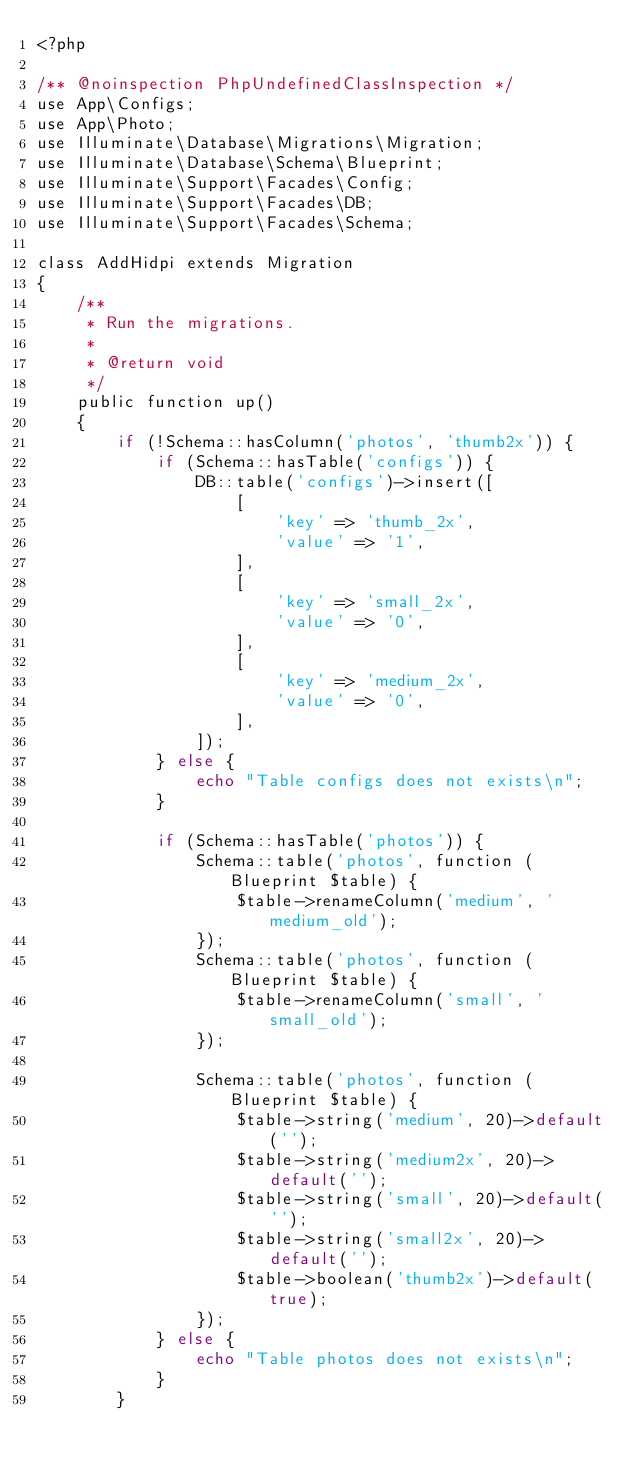<code> <loc_0><loc_0><loc_500><loc_500><_PHP_><?php

/** @noinspection PhpUndefinedClassInspection */
use App\Configs;
use App\Photo;
use Illuminate\Database\Migrations\Migration;
use Illuminate\Database\Schema\Blueprint;
use Illuminate\Support\Facades\Config;
use Illuminate\Support\Facades\DB;
use Illuminate\Support\Facades\Schema;

class AddHidpi extends Migration
{
	/**
	 * Run the migrations.
	 *
	 * @return void
	 */
	public function up()
	{
		if (!Schema::hasColumn('photos', 'thumb2x')) {
			if (Schema::hasTable('configs')) {
				DB::table('configs')->insert([
					[
						'key' => 'thumb_2x',
						'value' => '1',
					],
					[
						'key' => 'small_2x',
						'value' => '0',
					],
					[
						'key' => 'medium_2x',
						'value' => '0',
					],
				]);
			} else {
				echo "Table configs does not exists\n";
			}

			if (Schema::hasTable('photos')) {
				Schema::table('photos', function (Blueprint $table) {
					$table->renameColumn('medium', 'medium_old');
				});
				Schema::table('photos', function (Blueprint $table) {
					$table->renameColumn('small', 'small_old');
				});

				Schema::table('photos', function (Blueprint $table) {
					$table->string('medium', 20)->default('');
					$table->string('medium2x', 20)->default('');
					$table->string('small', 20)->default('');
					$table->string('small2x', 20)->default('');
					$table->boolean('thumb2x')->default(true);
				});
			} else {
				echo "Table photos does not exists\n";
			}
		}</code> 